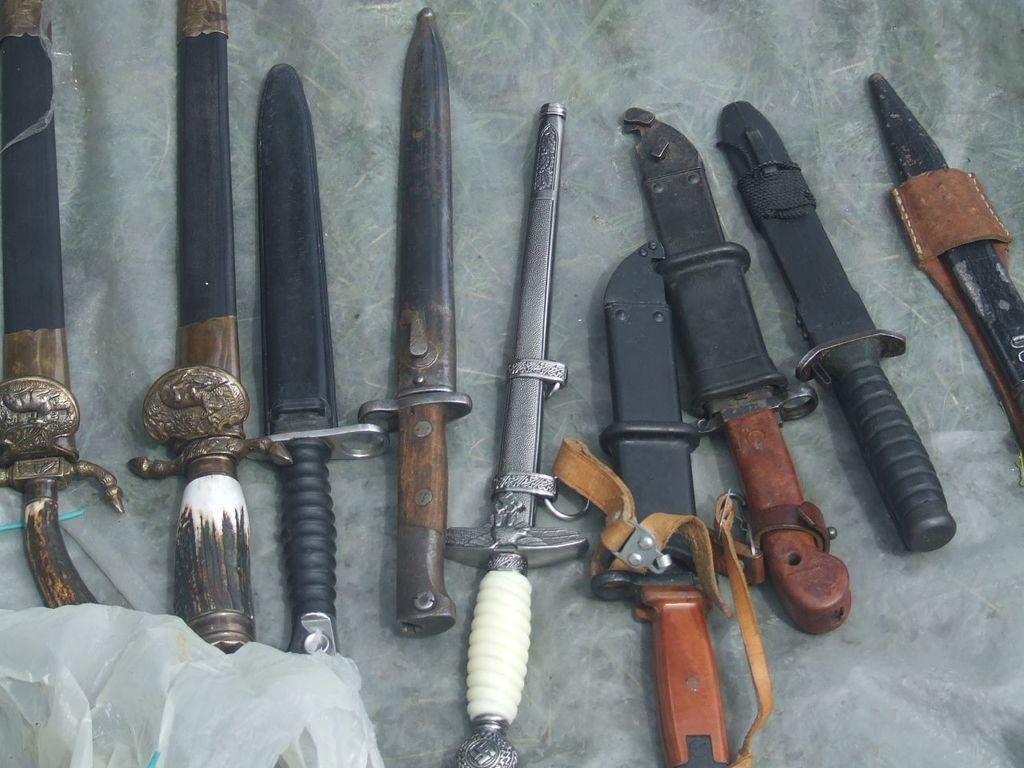What objects are present in the image? There are weapons in the image. Where are the weapons located? The weapons are placed on a surface. What can be seen on the left side of the image? There is a cover on the left side of the image. Can you tell me how many times the weapons are swinging in the image? There is no indication in the image that the weapons are swinging; they are placed on a surface. 